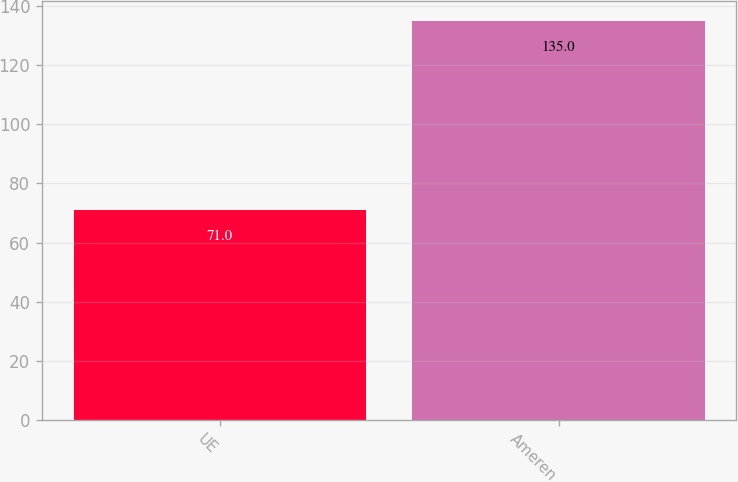Convert chart to OTSL. <chart><loc_0><loc_0><loc_500><loc_500><bar_chart><fcel>UE<fcel>Ameren<nl><fcel>71<fcel>135<nl></chart> 